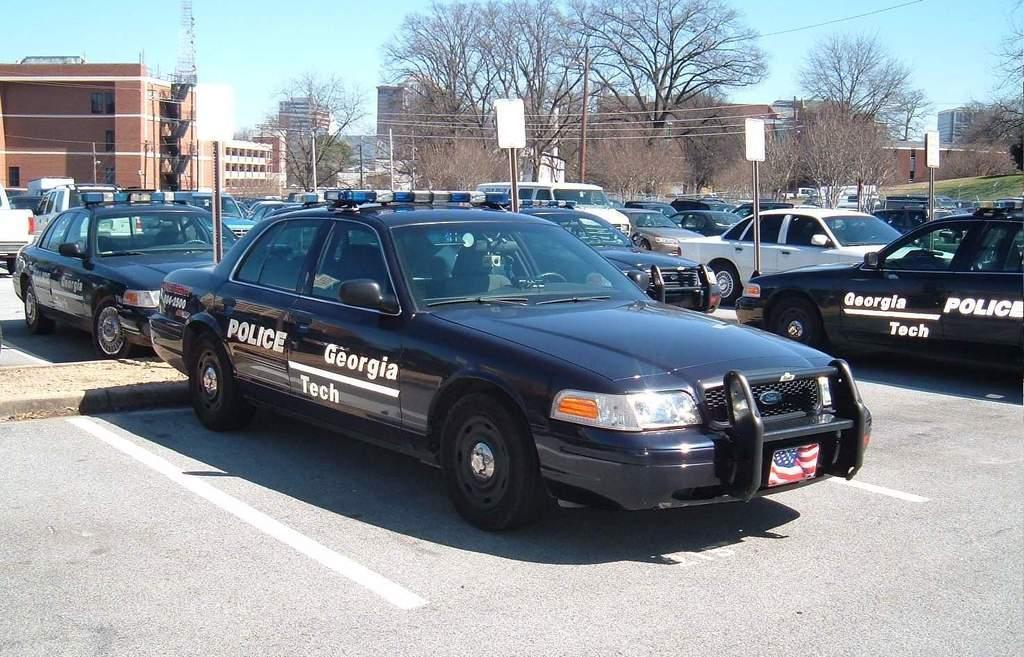How would you summarize this image in a sentence or two? There are many cars parked on the parking area. On the cars something is written. There are boards with poles. In the background there are trees, buildings and sky. 